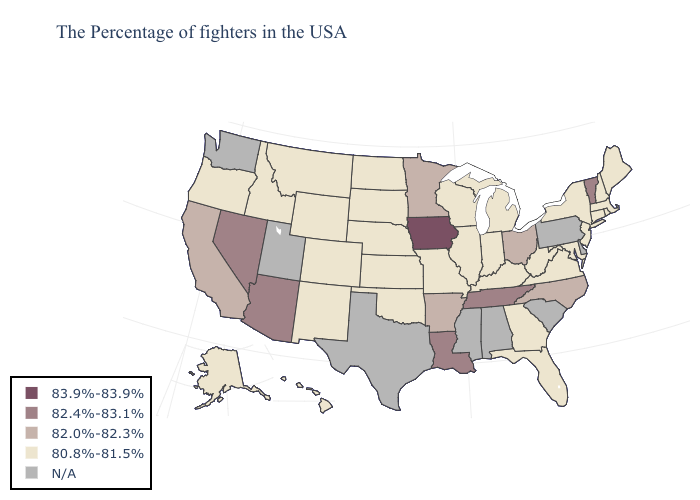What is the value of Colorado?
Give a very brief answer. 80.8%-81.5%. Is the legend a continuous bar?
Quick response, please. No. Among the states that border West Virginia , does Ohio have the highest value?
Be succinct. Yes. What is the lowest value in states that border New Hampshire?
Concise answer only. 80.8%-81.5%. Name the states that have a value in the range 80.8%-81.5%?
Be succinct. Maine, Massachusetts, Rhode Island, New Hampshire, Connecticut, New York, New Jersey, Maryland, Virginia, West Virginia, Florida, Georgia, Michigan, Kentucky, Indiana, Wisconsin, Illinois, Missouri, Kansas, Nebraska, Oklahoma, South Dakota, North Dakota, Wyoming, Colorado, New Mexico, Montana, Idaho, Oregon, Alaska, Hawaii. Which states have the lowest value in the USA?
Be succinct. Maine, Massachusetts, Rhode Island, New Hampshire, Connecticut, New York, New Jersey, Maryland, Virginia, West Virginia, Florida, Georgia, Michigan, Kentucky, Indiana, Wisconsin, Illinois, Missouri, Kansas, Nebraska, Oklahoma, South Dakota, North Dakota, Wyoming, Colorado, New Mexico, Montana, Idaho, Oregon, Alaska, Hawaii. How many symbols are there in the legend?
Short answer required. 5. Name the states that have a value in the range 82.0%-82.3%?
Be succinct. North Carolina, Ohio, Arkansas, Minnesota, California. Which states have the lowest value in the Northeast?
Answer briefly. Maine, Massachusetts, Rhode Island, New Hampshire, Connecticut, New York, New Jersey. What is the highest value in the USA?
Give a very brief answer. 83.9%-83.9%. What is the lowest value in states that border New Mexico?
Quick response, please. 80.8%-81.5%. Is the legend a continuous bar?
Keep it brief. No. 